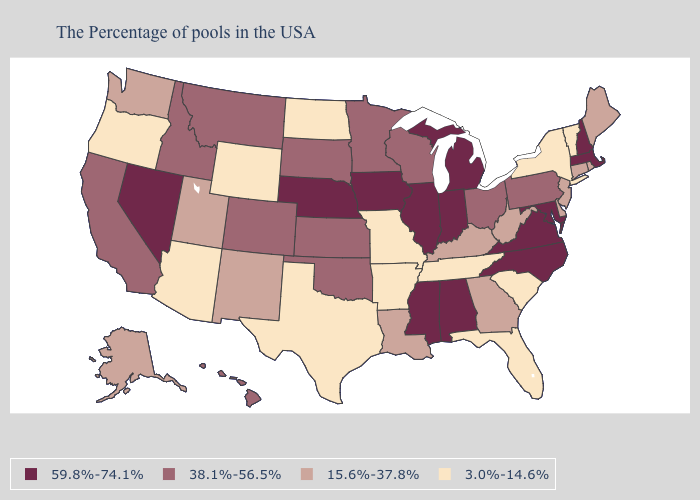How many symbols are there in the legend?
Quick response, please. 4. What is the lowest value in states that border Oregon?
Give a very brief answer. 15.6%-37.8%. What is the value of Oregon?
Be succinct. 3.0%-14.6%. Does Nevada have the highest value in the USA?
Answer briefly. Yes. What is the value of Florida?
Write a very short answer. 3.0%-14.6%. Among the states that border West Virginia , does Maryland have the highest value?
Quick response, please. Yes. Among the states that border Nevada , does California have the highest value?
Keep it brief. Yes. Name the states that have a value in the range 15.6%-37.8%?
Concise answer only. Maine, Rhode Island, Connecticut, New Jersey, Delaware, West Virginia, Georgia, Kentucky, Louisiana, New Mexico, Utah, Washington, Alaska. What is the lowest value in states that border North Dakota?
Answer briefly. 38.1%-56.5%. Among the states that border Michigan , which have the lowest value?
Write a very short answer. Ohio, Wisconsin. Which states have the lowest value in the USA?
Keep it brief. Vermont, New York, South Carolina, Florida, Tennessee, Missouri, Arkansas, Texas, North Dakota, Wyoming, Arizona, Oregon. Does Massachusetts have the highest value in the USA?
Short answer required. Yes. What is the value of Colorado?
Answer briefly. 38.1%-56.5%. Name the states that have a value in the range 59.8%-74.1%?
Quick response, please. Massachusetts, New Hampshire, Maryland, Virginia, North Carolina, Michigan, Indiana, Alabama, Illinois, Mississippi, Iowa, Nebraska, Nevada. Does Pennsylvania have the same value as Kentucky?
Quick response, please. No. 